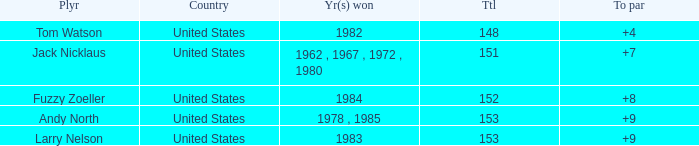What is Andy North with a To par greater than 8 Country? United States. 